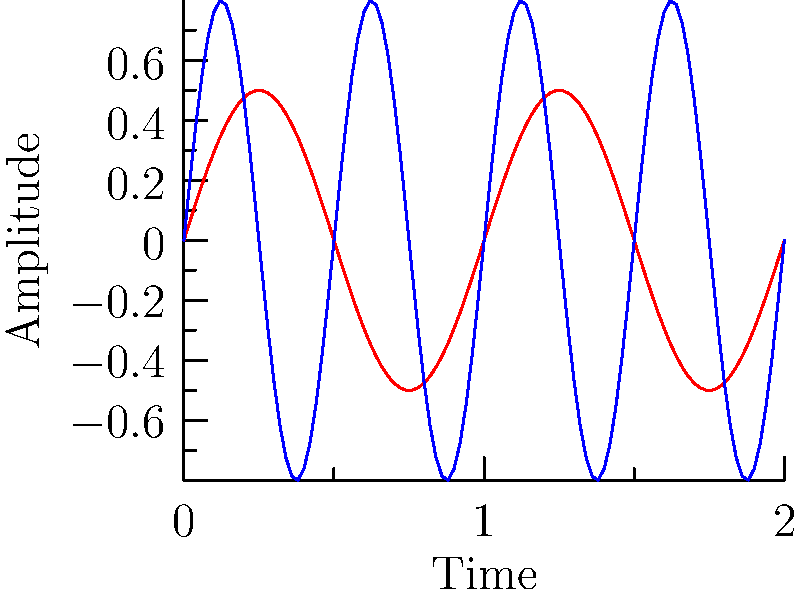In the diagram above, which waveform typically represents the more complex and higher frequency sounds often found in electronic music synths? To answer this question, we need to analyze the characteristics of both waveforms:

1. The red waveform (labeled "Old-school hip hop beat"):
   - Has a lower frequency (completes fewer cycles in the given time frame)
   - Has a smoother, more sinusoidal shape
   - Represents simpler, more basic sounds typical of old-school hip hop beats

2. The blue waveform (labeled "Electronic music synth"):
   - Has a higher frequency (completes more cycles in the given time frame)
   - Shows more rapid oscillations
   - Represents more complex, higher frequency sounds typical of electronic music synths

3. In electronic music, synthesizers often produce sounds with:
   - Higher frequencies
   - More complex waveforms
   - Rapid modulations and oscillations

4. These characteristics allow for the creation of unique, often "futuristic" sounds that are a hallmark of electronic music.

5. The blue waveform exhibits these properties, with its higher frequency and more rapid oscillations.

Therefore, the blue waveform typically represents the more complex and higher frequency sounds often found in electronic music synths.
Answer: Blue waveform 